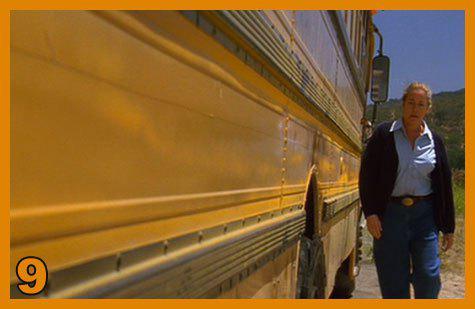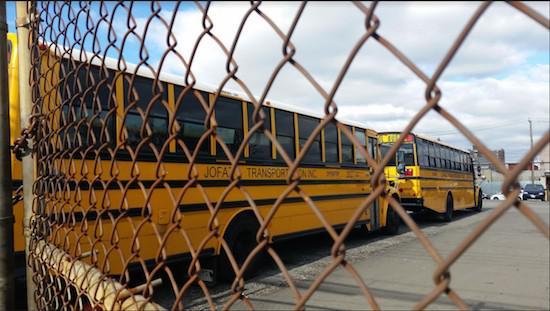The first image is the image on the left, the second image is the image on the right. Evaluate the accuracy of this statement regarding the images: "One image shows parked yellow school buses viewed through chain link fence, and the other image shows a 'diminishing perspective' view of the length of at least one bus.". Is it true? Answer yes or no. Yes. The first image is the image on the left, the second image is the image on the right. Examine the images to the left and right. Is the description "The buses on the right are parked in two columns that are close together." accurate? Answer yes or no. No. 